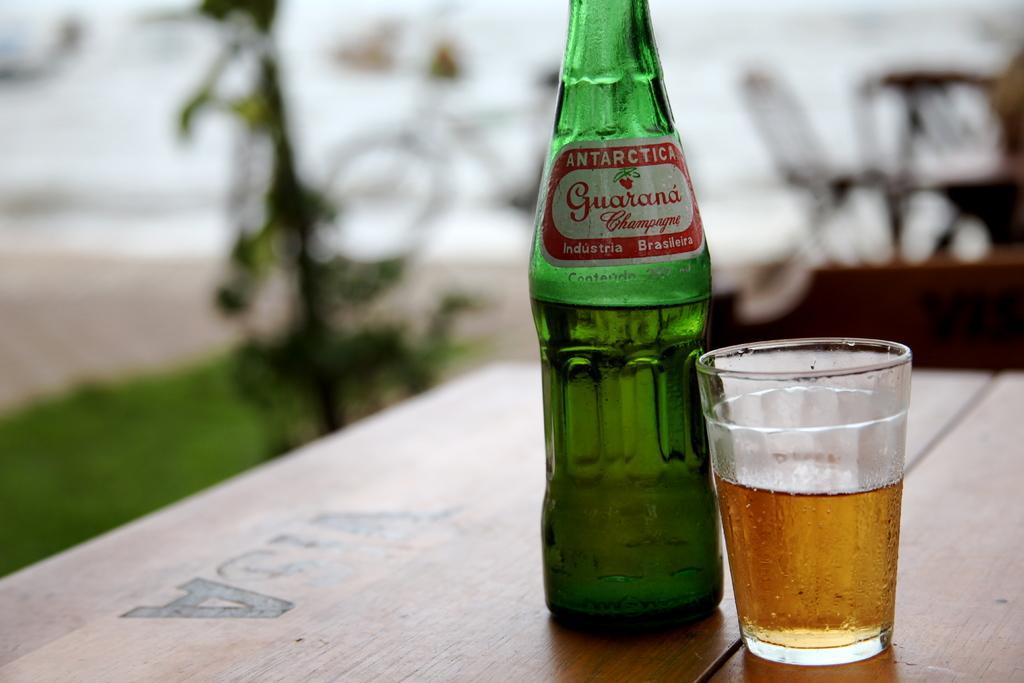Can you describe this image briefly? In this image I can see bottle and glass on the table. 